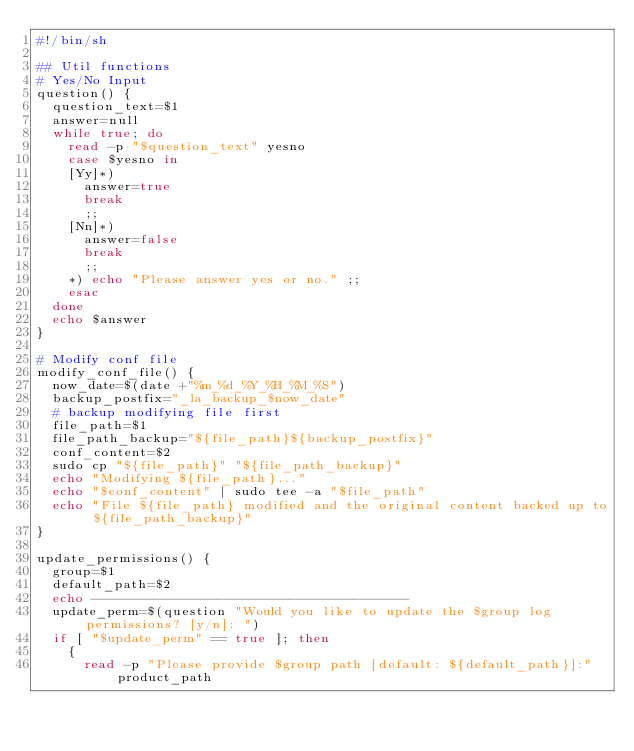<code> <loc_0><loc_0><loc_500><loc_500><_Bash_>#!/bin/sh

## Util functions
# Yes/No Input
question() {
  question_text=$1
  answer=null
  while true; do
    read -p "$question_text" yesno
    case $yesno in
    [Yy]*)
      answer=true
      break
      ;;
    [Nn]*)
      answer=false
      break
      ;;
    *) echo "Please answer yes or no." ;;
    esac
  done
  echo $answer
}

# Modify conf file
modify_conf_file() {
  now_date=$(date +"%m_%d_%Y_%H_%M_%S")
  backup_postfix="_la_backup_$now_date"
  # backup modifying file first
  file_path=$1
  file_path_backup="${file_path}${backup_postfix}"
  conf_content=$2
  sudo cp "${file_path}" "${file_path_backup}"
  echo "Modifying ${file_path}..."
  echo "$conf_content" | sudo tee -a "$file_path"
  echo "File ${file_path} modified and the original content backed up to ${file_path_backup}"
}

update_permissions() {
  group=$1
  default_path=$2
  echo ----------------------------------------
  update_perm=$(question "Would you like to update the $group log permissions? [y/n]: ")
  if [ "$update_perm" == true ]; then
    {
      read -p "Please provide $group path [default: ${default_path}]:" product_path</code> 